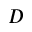Convert formula to latex. <formula><loc_0><loc_0><loc_500><loc_500>D</formula> 